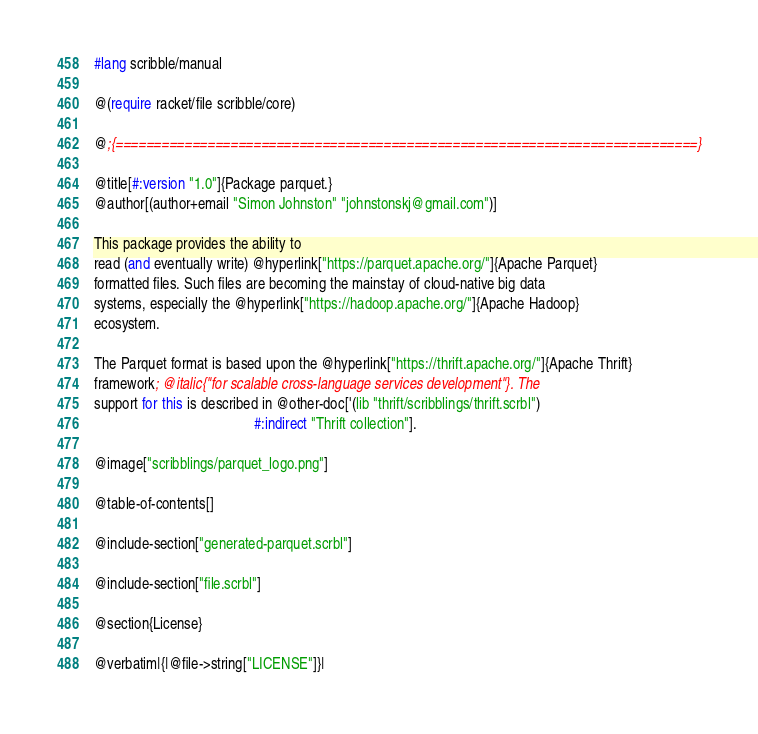Convert code to text. <code><loc_0><loc_0><loc_500><loc_500><_Racket_>#lang scribble/manual

@(require racket/file scribble/core)

@;{============================================================================}

@title[#:version "1.0"]{Package parquet.}
@author[(author+email "Simon Johnston" "johnstonskj@gmail.com")]

This package provides the ability to
read (and eventually write) @hyperlink["https://parquet.apache.org/"]{Apache Parquet}
formatted files. Such files are becoming the mainstay of cloud-native big data
systems, especially the @hyperlink["https://hadoop.apache.org/"]{Apache Hadoop}
ecosystem.

The Parquet format is based upon the @hyperlink["https://thrift.apache.org/"]{Apache Thrift}
framework; @italic{"for scalable cross-language services development"}. The
support for this is described in @other-doc['(lib "thrift/scribblings/thrift.scrbl")
                                            #:indirect "Thrift collection"].

@image["scribblings/parquet_logo.png"] 

@table-of-contents[]

@include-section["generated-parquet.scrbl"]

@include-section["file.scrbl"]

@section{License}

@verbatim|{|@file->string["LICENSE"]}|
</code> 